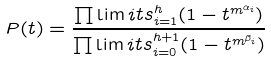<formula> <loc_0><loc_0><loc_500><loc_500>P ( t ) = \frac { \prod \lim i t s _ { i = 1 } ^ { h } ( 1 - t ^ { m ^ { \alpha _ { i } } } ) } { \prod \lim i t s _ { i = 0 } ^ { h + 1 } ( 1 - t ^ { m ^ { \beta _ { i } } } ) }</formula> 